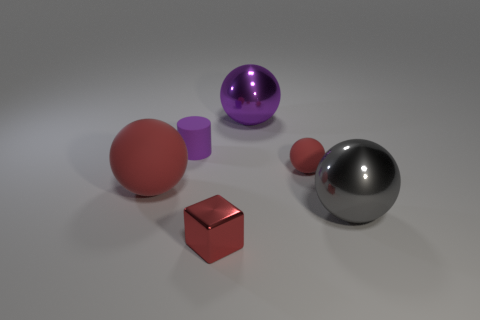There is a thing that is both behind the small rubber ball and in front of the big purple shiny sphere; what shape is it?
Your answer should be compact. Cylinder. What number of red shiny cubes are there?
Your response must be concise. 1. What material is the object that is in front of the shiny sphere in front of the small matte thing left of the small ball?
Provide a short and direct response. Metal. What number of big purple balls are to the right of the small object to the right of the small red metal thing?
Provide a short and direct response. 0. What is the color of the large matte thing that is the same shape as the large gray metal object?
Provide a short and direct response. Red. Is the material of the big purple thing the same as the gray ball?
Keep it short and to the point. Yes. How many spheres are matte objects or tiny red matte objects?
Ensure brevity in your answer.  2. There is a red ball to the left of the big purple object on the left side of the red thing that is on the right side of the big purple sphere; what is its size?
Offer a very short reply. Large. There is a purple metallic object that is the same shape as the small red rubber thing; what is its size?
Keep it short and to the point. Large. There is a small purple matte cylinder; how many small cylinders are left of it?
Your response must be concise. 0. 